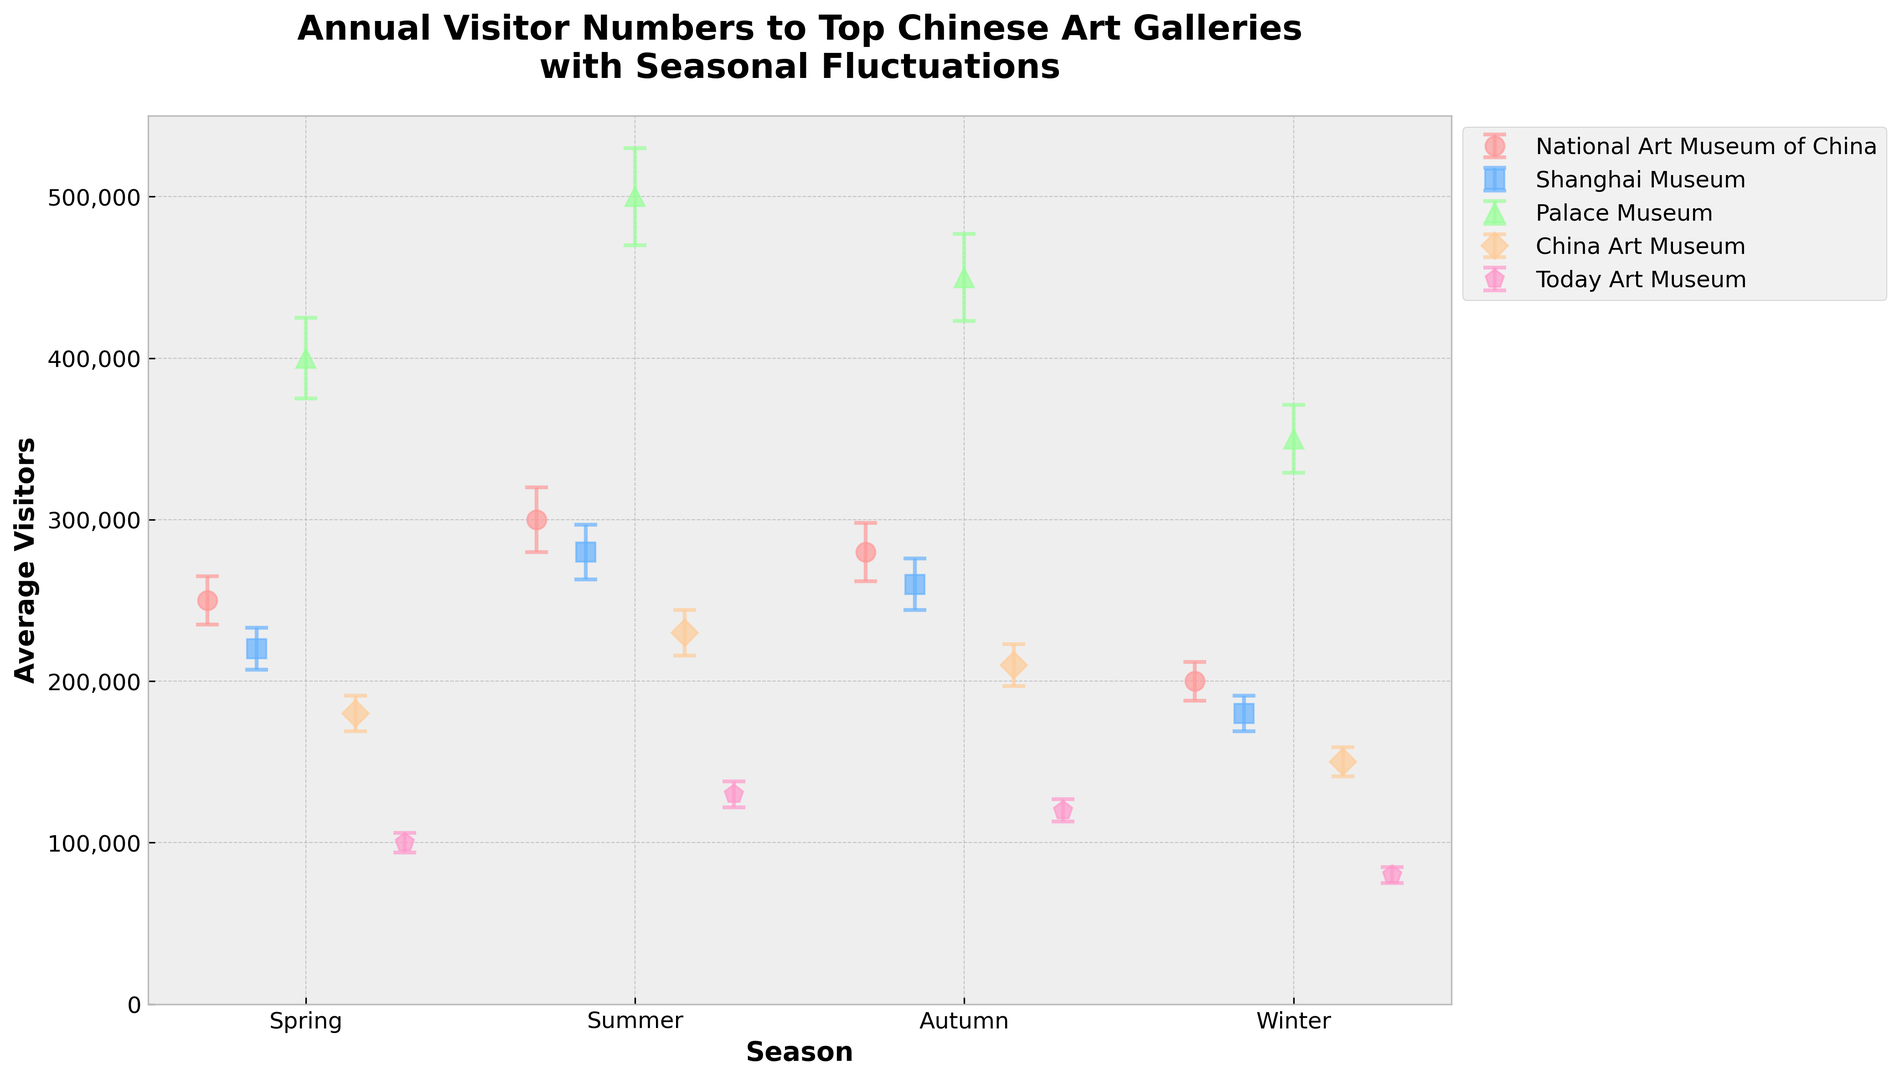Which gallery has the highest average number of visitors in the summer? To determine which gallery has the highest average number of visitors in the summer, look at the summer (second data point for each gallery) error bars. The Palace Museum has the highest value of approximately 500,000 visitors.
Answer: Palace Museum What is the difference in average visitors between the Palace Museum and the Today Art Museum during autumn? Subtract the average number of visitors to the Today Art Museum in autumn (120,000) from those to the Palace Museum in autumn (450,000). 450,000 - 120,000 = 330,000.
Answer: 330,000 Which gallery shows the most consistent visitor numbers across the seasons (i.e., the smallest difference between the highest and lowest average visitor numbers)? To find the gallery with the smallest difference, calculate the difference between the highest and lowest values for each gallery and compare. For Today Art Museum: 130,000-80,000 = 50,000, for China Art Museum: 230,000-150,000 = 80,000, for Palace Museum: 500,000-350,000 = 150,000, for Shanghai Museum: 280,000-180,000 = 100,000, for National Art Museum of China: 300,000-200,000 = 100,000. The Today Art Museum has the smallest difference.
Answer: Today Art Museum How does the average number of visitors in the winter at the National Art Museum of China compare to those at the Shanghai Museum? Compare the heights of the winter error bars for both museums. The National Art Museum of China has 200,000 visitors in winter, whereas the Shanghai Museum has 180,000 visitors in winter. Therefore, the National Art Museum of China has more visitors.
Answer: National Art Museum of China Which gallery experiences the greatest drop in visitors from summer to winter? Calculate the difference between the summer and winter visitors for all galleries. For National Art Museum of China: 300,000-200,000 = 100,000, for Shanghai Museum: 280,000-180,000 = 100,000, for Palace Museum: 500,000-350,000 = 150,000, for China Art Museum: 230,000-150,000 = 80,000, for Today Art Museum: 130,000-80,000 = 50,000. The Palace Museum experiences the greatest drop of 150,000 visitors.
Answer: Palace Museum What is the sum of the average visitors for the Palace Museum in all seasons? Add the average visitors for all seasons at the Palace Museum. Spring: 400,000, Summer: 500,000, Autumn: 450,000, Winter: 350,000, leading to a sum of 400,000 + 500,000 + 450,000 + 350,000 = 1,700,000.
Answer: 1,700,000 Which gallery has the highest average number of visitors in spring? Compare the heights of the spring error bars for all galleries. The Palace Museum has around 400,000 visitors, which is higher than the other galleries.
Answer: Palace Museum Is the number of visitors in autumn at the China Art Museum greater than in spring at the Today Art Museum? Compare the heights of the error bars for these specific data points. The China Art Museum in autumn has 210,000 visitors, while the Today Art Museum in spring has 100,000 visitors, so yes, the number is greater.
Answer: Yes 